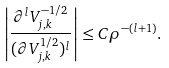<formula> <loc_0><loc_0><loc_500><loc_500>\left | \frac { \partial ^ { l } V _ { j , k } ^ { - 1 / 2 } } { ( \partial V _ { j , k } ^ { 1 / 2 } ) ^ { l } } \right | \leq C \rho ^ { - ( l + 1 ) } .</formula> 